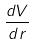Convert formula to latex. <formula><loc_0><loc_0><loc_500><loc_500>\frac { d V } { d r }</formula> 